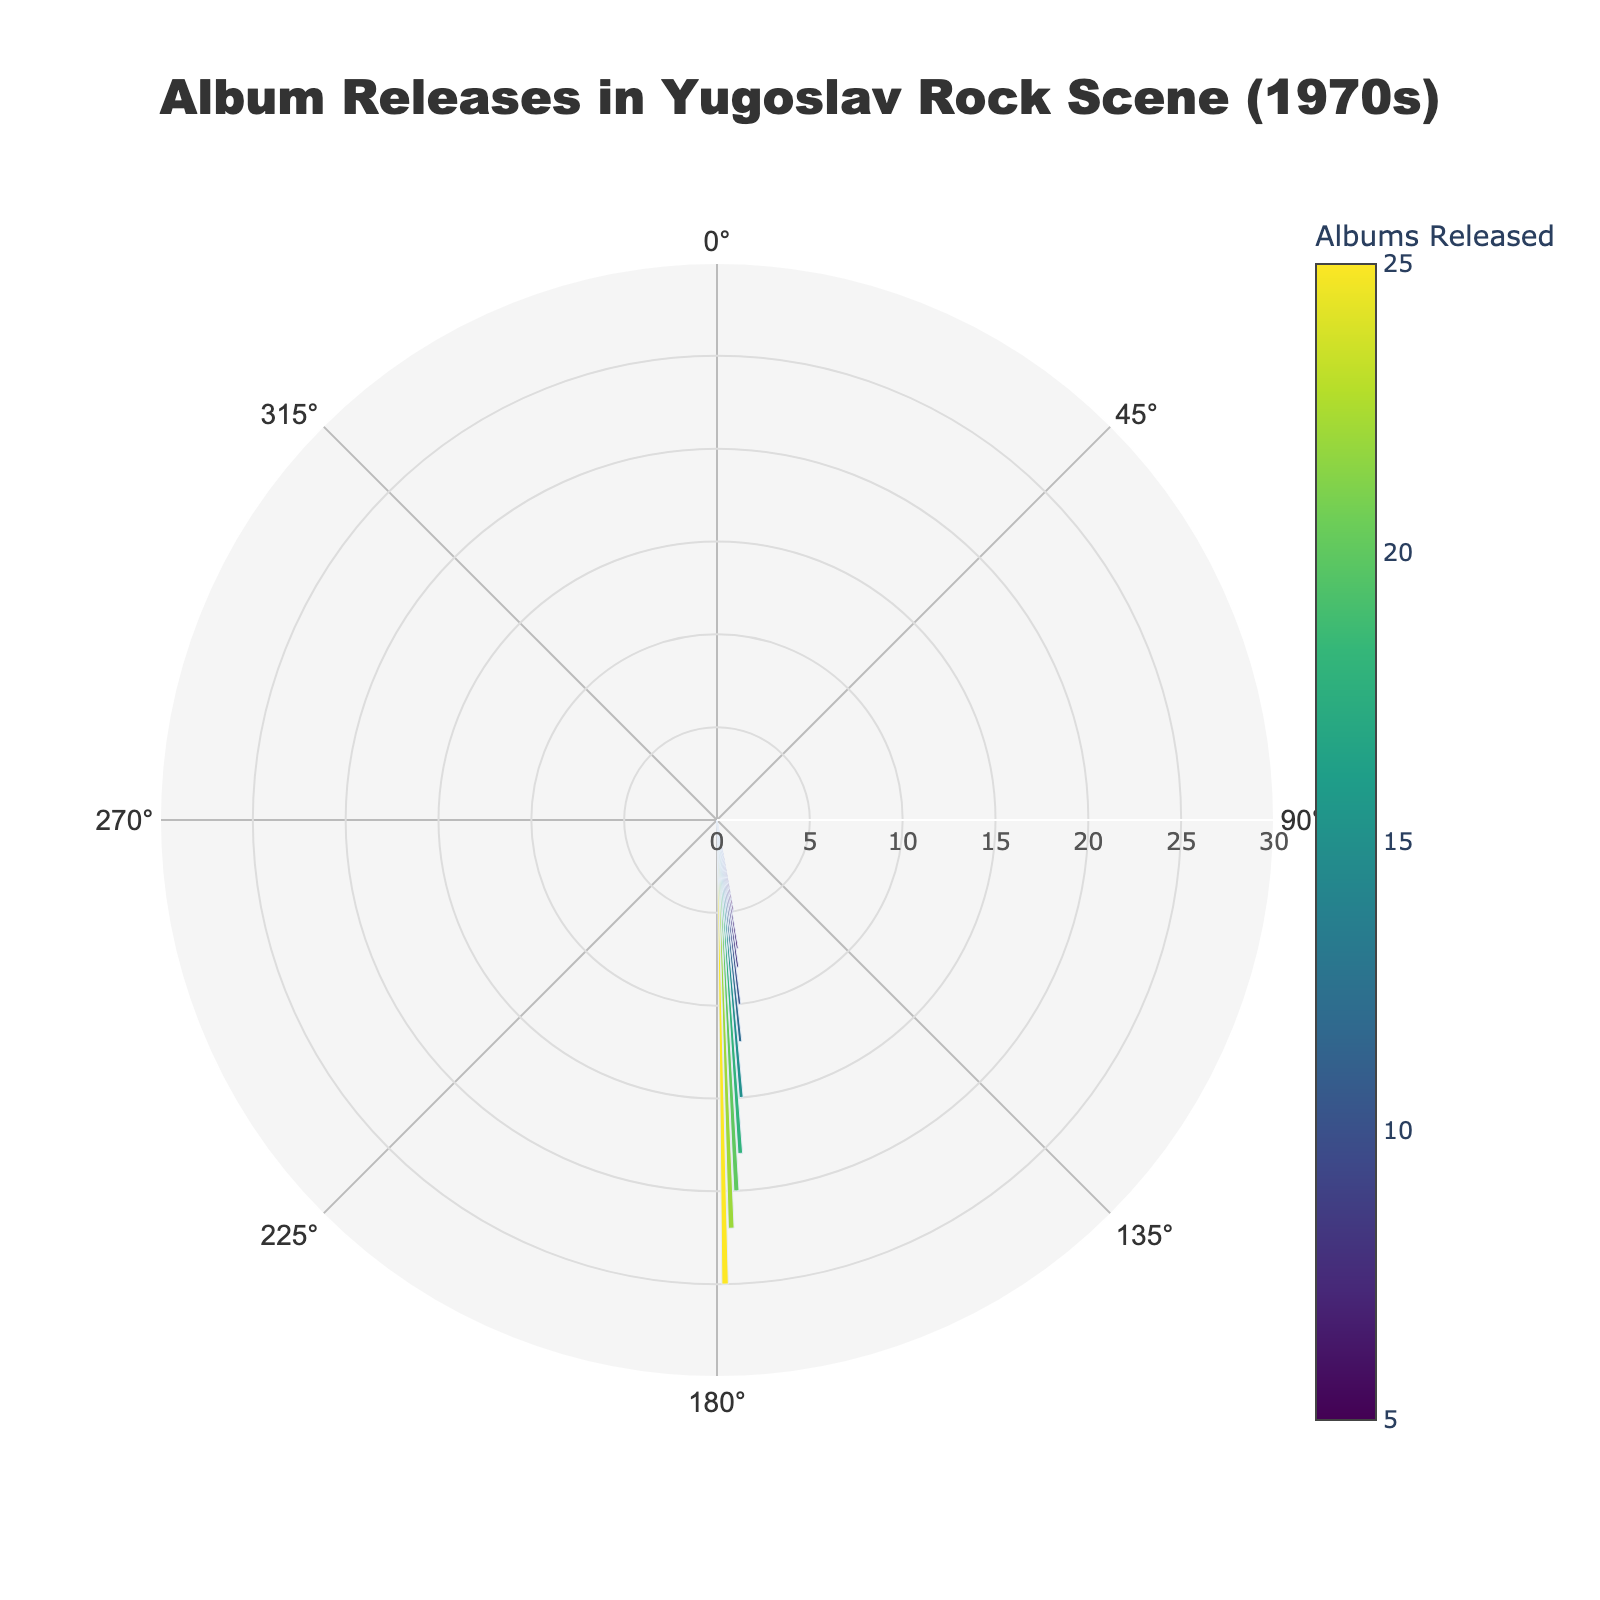what year had the highest number of album releases? The figure shows the number of albums released per year in a circular format with bars of varying lengths. The bars represent the number of albums, and the longest bar correlates to the highest number of albums. For the longest bar, check its label, which corresponds to the year.
Answer: 1979 which year had exactly 7 albums released? The figure provides hover text for each bar, showing the number of albums released in each year. By finding a bar labeled with '7' albums, you can determine the corresponding year.
Answer: 1971 how many years had more than 15 albums released? To find this, count the number of bars that extend beyond the 15-albums mark. Each bar represents a different year, so sum up the years meeting this criterion.
Answer: 4 what is the direction of the angular axis labels? The figure's angular axis labels (years) are rotated in a specific direction, which is mentioned below the axis customization section in the layout.
Answer: clockwise calculate the average number of albums released over the decade Sum the number of albums released each year (5+7+8+10+12+15+18+20+22+25) and divide by the number of years (10).
Answer: 14.2 how does the album release trend change from 1970 to 1979? By examining the lengths of the bars from 1970 to 1979, you can observe the overall trend in album releases. The bars grow longer as the years progress. This indicates an increasing trend in the number of albums released annually.
Answer: increasing compare the number of albums released in 1975 and 1978 Locate and compare the lengths of the bars for 1975 and 1978. The hover text will confirm the exact numbers. 1975 has 15 albums, and 1978 has 22 albums.
Answer: 1978 had more is there a year when the number of albums released decreased compared to the previous year? Check each consecutive pair of bars to see if the length of any bar is shorter than the bar immediately before it.
Answer: no what's the median number of albums released? Arrange the values (5, 7, 8, 10, 12, 15, 18, 20, 22, 25) in ascending order. The median is the middle value, which is the average of the 5th and 6th values (12 and 15), since there is an even number of years.
Answer: 13.5 how many albums were released in total during the decade? Sum the number of albums released each year: 5+7+8+10+12+15+18+20+22+25.
Answer: 142 